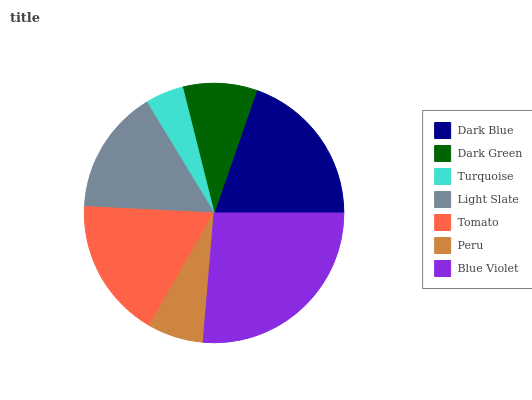Is Turquoise the minimum?
Answer yes or no. Yes. Is Blue Violet the maximum?
Answer yes or no. Yes. Is Dark Green the minimum?
Answer yes or no. No. Is Dark Green the maximum?
Answer yes or no. No. Is Dark Blue greater than Dark Green?
Answer yes or no. Yes. Is Dark Green less than Dark Blue?
Answer yes or no. Yes. Is Dark Green greater than Dark Blue?
Answer yes or no. No. Is Dark Blue less than Dark Green?
Answer yes or no. No. Is Light Slate the high median?
Answer yes or no. Yes. Is Light Slate the low median?
Answer yes or no. Yes. Is Blue Violet the high median?
Answer yes or no. No. Is Blue Violet the low median?
Answer yes or no. No. 